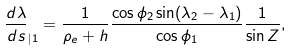Convert formula to latex. <formula><loc_0><loc_0><loc_500><loc_500>\frac { d \lambda } { d s } _ { | 1 } = \frac { 1 } { \rho _ { e } + h } \frac { \cos \phi _ { 2 } \sin ( \lambda _ { 2 } - \lambda _ { 1 } ) } { \cos \phi _ { 1 } } \frac { 1 } { \sin Z } ,</formula> 